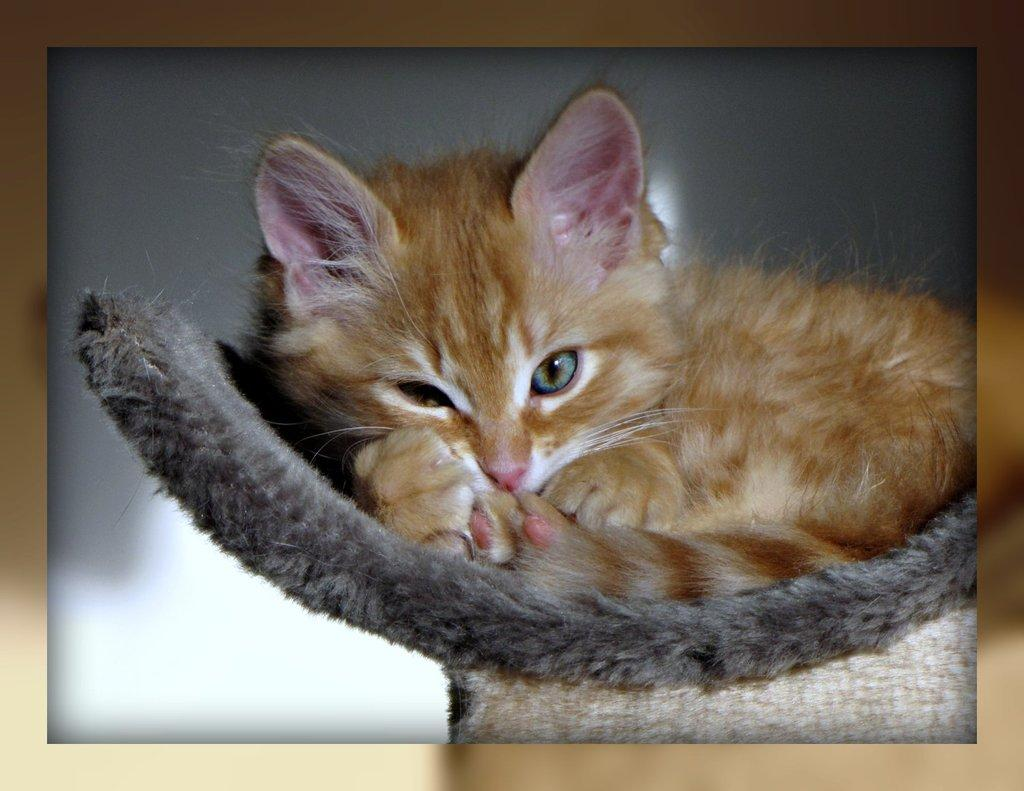What animal is present in the image? There is a cat in the image. What is the cat sitting in? The cat is in a black color object. What color is the background of the image? The background of the image is in grey color. How many birds are playing with the toys in the image? There are no birds or toys present in the image; it features a cat in a black object with a grey background. 